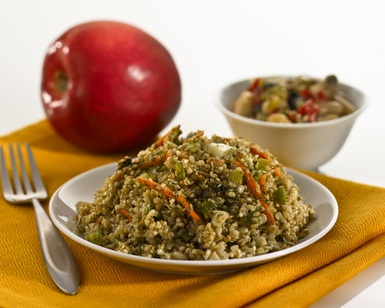Describe the objects in this image and their specific colors. I can see apple in white, brown, and maroon tones, bowl in white, tan, and olive tones, bowl in white, tan, darkgray, lightgray, and maroon tones, and fork in white, gray, and darkgray tones in this image. 